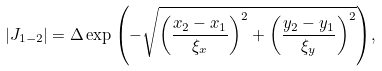<formula> <loc_0><loc_0><loc_500><loc_500>| J _ { 1 - 2 } | = \Delta \exp { \left ( - \sqrt { \left ( \frac { x _ { 2 } - x _ { 1 } } { \xi _ { x } } \right ) ^ { 2 } + \left ( \frac { y _ { 2 } - y _ { 1 } } { \xi _ { y } } \right ) ^ { 2 } } \right ) } ,</formula> 